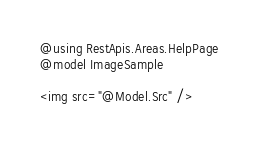<code> <loc_0><loc_0><loc_500><loc_500><_C#_>@using RestApis.Areas.HelpPage
@model ImageSample

<img src="@Model.Src" /></code> 